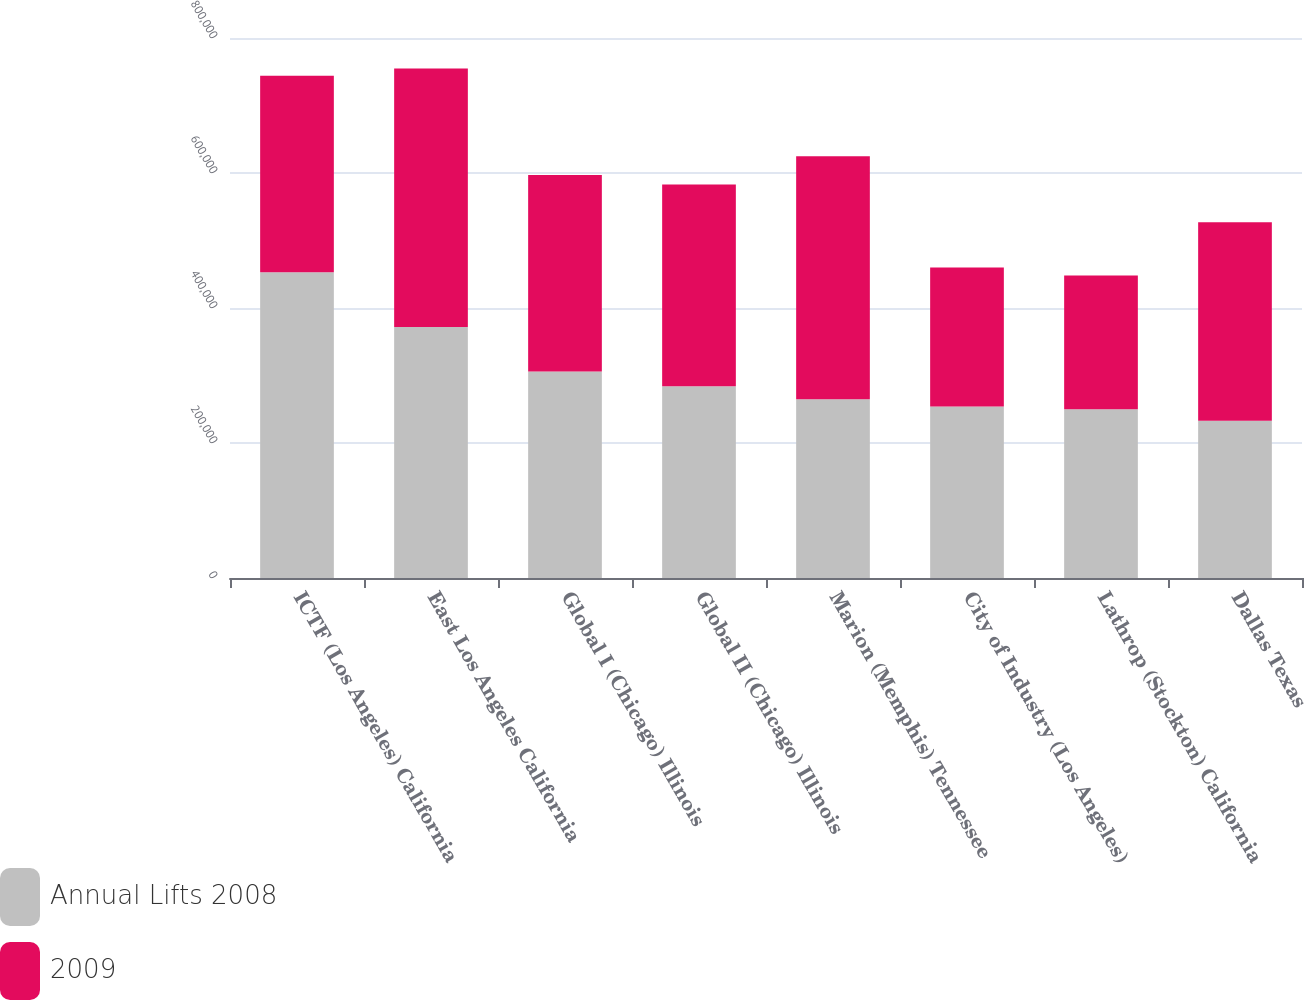Convert chart. <chart><loc_0><loc_0><loc_500><loc_500><stacked_bar_chart><ecel><fcel>ICTF (Los Angeles) California<fcel>East Los Angeles California<fcel>Global I (Chicago) Illinois<fcel>Global II (Chicago) Illinois<fcel>Marion (Memphis) Tennessee<fcel>City of Industry (Los Angeles)<fcel>Lathrop (Stockton) California<fcel>Dallas Texas<nl><fcel>Annual Lifts 2008<fcel>453000<fcel>372000<fcel>306000<fcel>284000<fcel>265000<fcel>254000<fcel>250000<fcel>233000<nl><fcel>2009<fcel>291000<fcel>383000<fcel>291000<fcel>299000<fcel>360000<fcel>206000<fcel>198000<fcel>294000<nl></chart> 